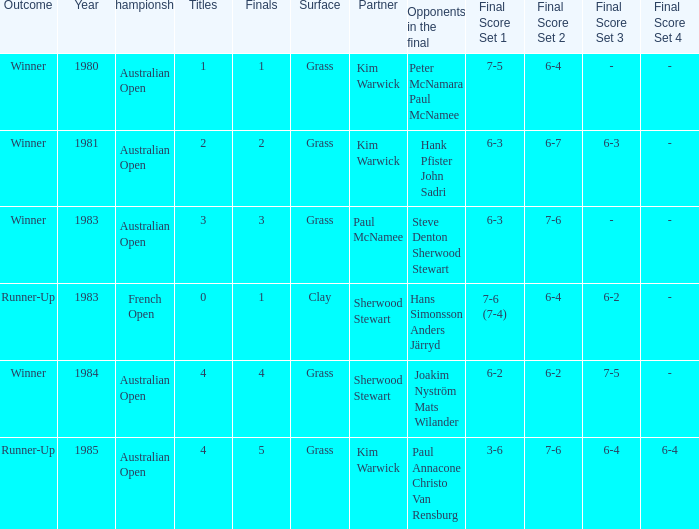How many different partners were played with during French Open (0/1)? 1.0. 